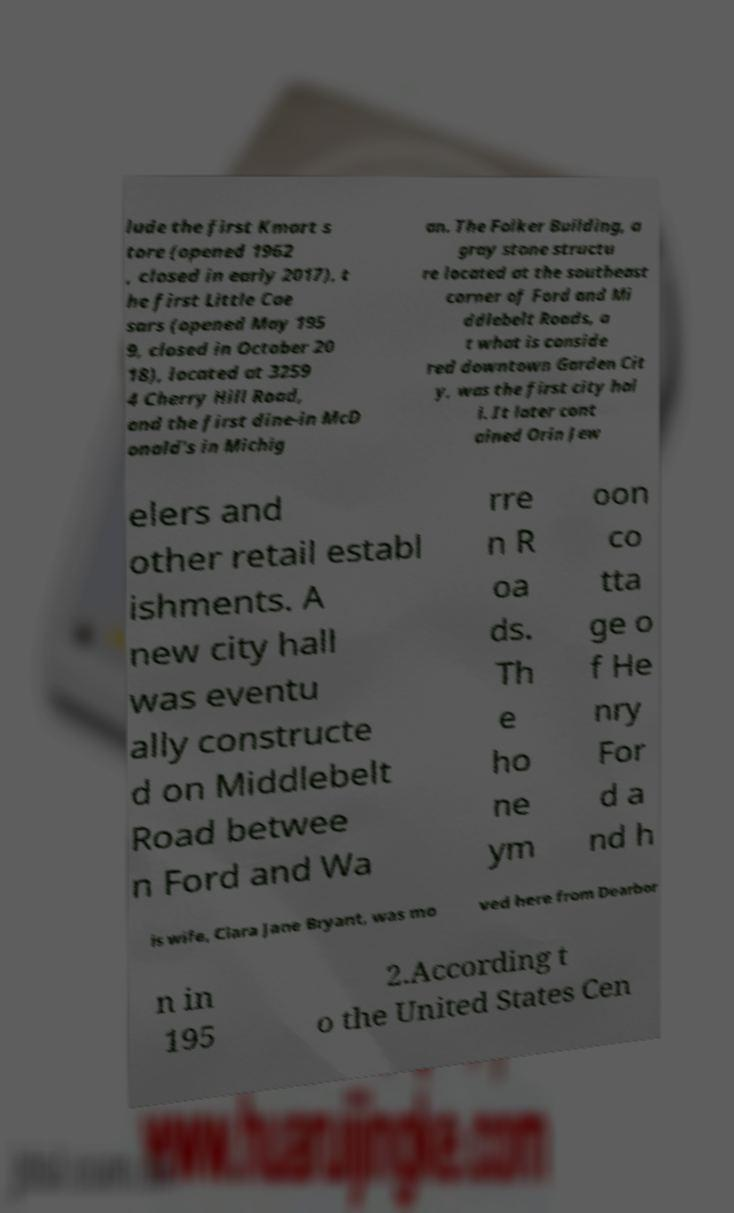Can you accurately transcribe the text from the provided image for me? lude the first Kmart s tore (opened 1962 , closed in early 2017), t he first Little Cae sars (opened May 195 9, closed in October 20 18), located at 3259 4 Cherry Hill Road, and the first dine-in McD onald's in Michig an. The Folker Building, a gray stone structu re located at the southeast corner of Ford and Mi ddlebelt Roads, a t what is conside red downtown Garden Cit y, was the first city hal l. It later cont ained Orin Jew elers and other retail establ ishments. A new city hall was eventu ally constructe d on Middlebelt Road betwee n Ford and Wa rre n R oa ds. Th e ho ne ym oon co tta ge o f He nry For d a nd h is wife, Clara Jane Bryant, was mo ved here from Dearbor n in 195 2.According t o the United States Cen 